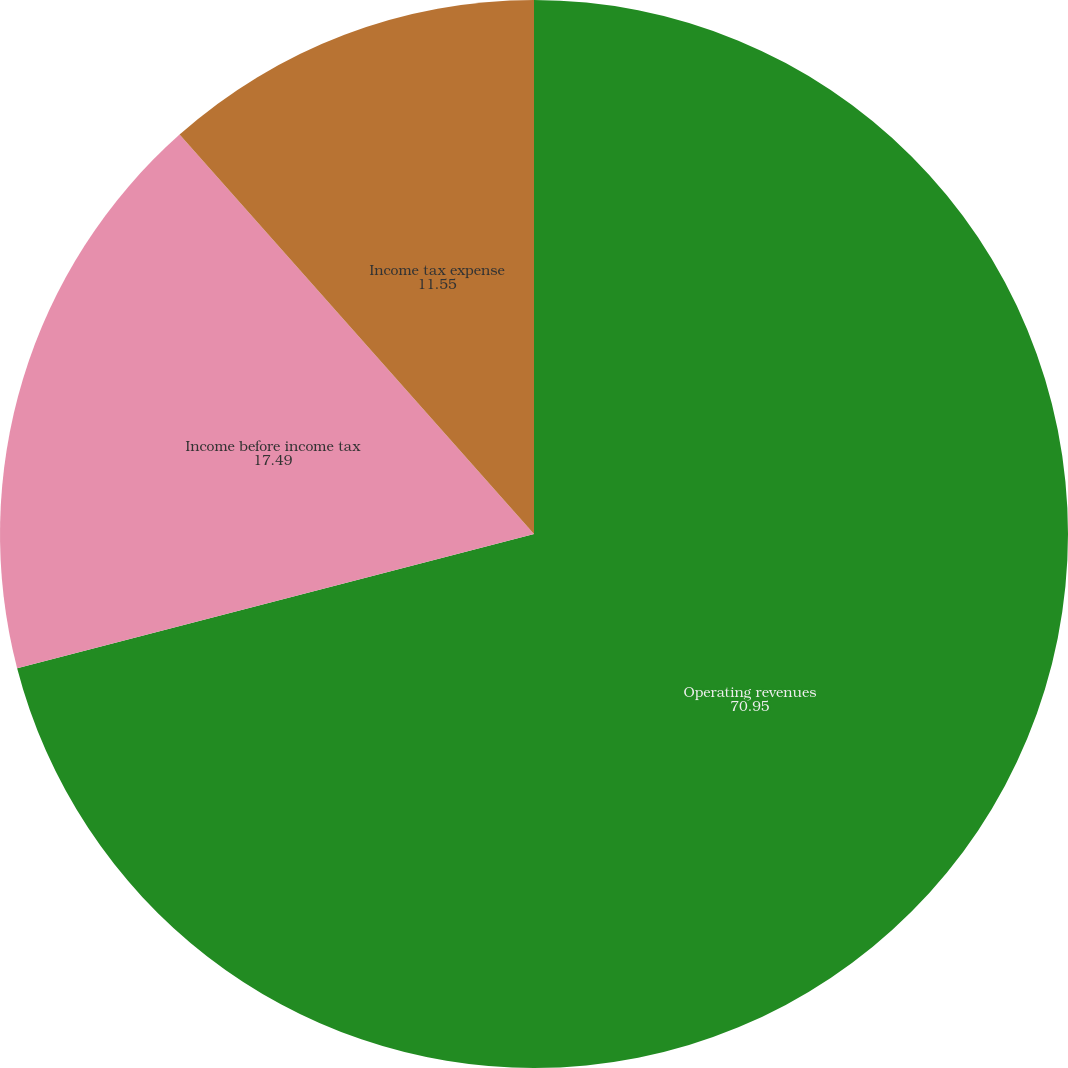Convert chart to OTSL. <chart><loc_0><loc_0><loc_500><loc_500><pie_chart><fcel>Operating revenues<fcel>Income before income tax<fcel>Income tax expense<nl><fcel>70.95%<fcel>17.49%<fcel>11.55%<nl></chart> 